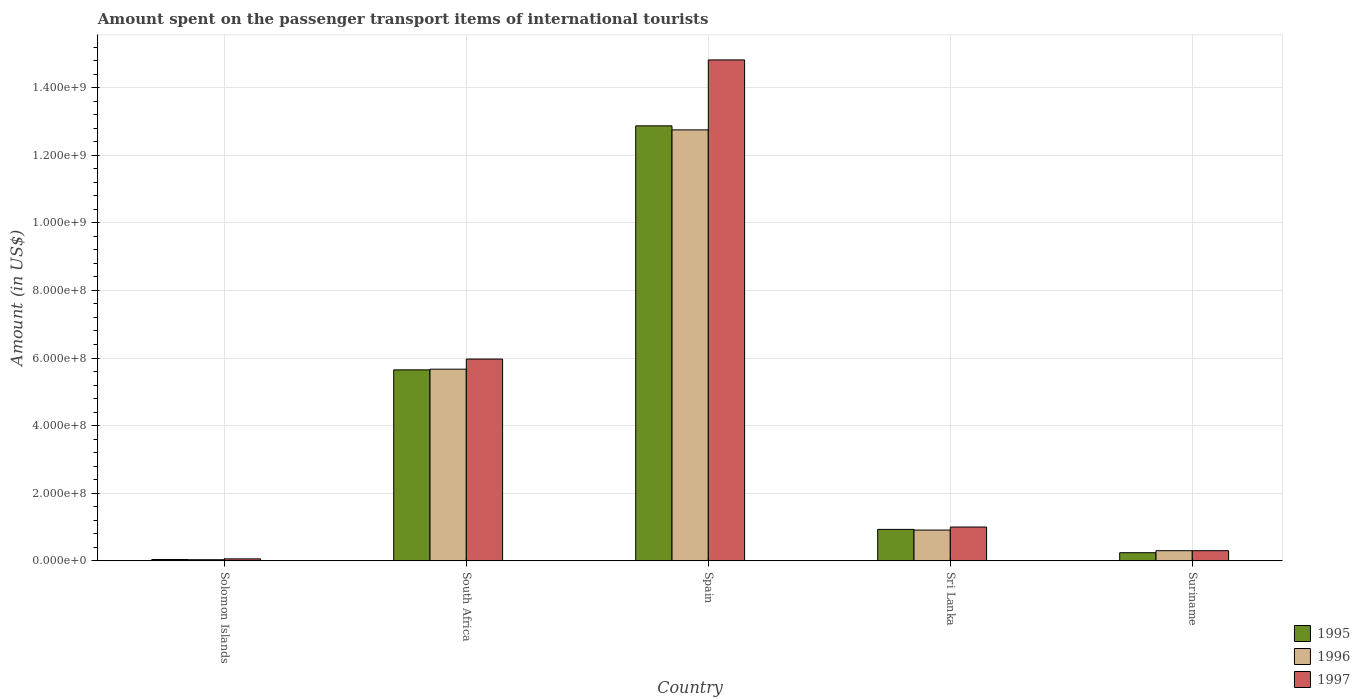Are the number of bars per tick equal to the number of legend labels?
Keep it short and to the point. Yes. Are the number of bars on each tick of the X-axis equal?
Ensure brevity in your answer.  Yes. How many bars are there on the 3rd tick from the right?
Ensure brevity in your answer.  3. What is the label of the 4th group of bars from the left?
Make the answer very short. Sri Lanka. In how many cases, is the number of bars for a given country not equal to the number of legend labels?
Offer a very short reply. 0. What is the amount spent on the passenger transport items of international tourists in 1997 in South Africa?
Make the answer very short. 5.97e+08. Across all countries, what is the maximum amount spent on the passenger transport items of international tourists in 1997?
Provide a short and direct response. 1.48e+09. Across all countries, what is the minimum amount spent on the passenger transport items of international tourists in 1996?
Offer a terse response. 3.30e+06. In which country was the amount spent on the passenger transport items of international tourists in 1995 maximum?
Make the answer very short. Spain. In which country was the amount spent on the passenger transport items of international tourists in 1996 minimum?
Give a very brief answer. Solomon Islands. What is the total amount spent on the passenger transport items of international tourists in 1995 in the graph?
Ensure brevity in your answer.  1.97e+09. What is the difference between the amount spent on the passenger transport items of international tourists in 1996 in Solomon Islands and that in Sri Lanka?
Provide a succinct answer. -8.77e+07. What is the difference between the amount spent on the passenger transport items of international tourists in 1997 in Sri Lanka and the amount spent on the passenger transport items of international tourists in 1995 in Spain?
Your answer should be compact. -1.19e+09. What is the average amount spent on the passenger transport items of international tourists in 1995 per country?
Make the answer very short. 3.95e+08. What is the difference between the amount spent on the passenger transport items of international tourists of/in 1996 and amount spent on the passenger transport items of international tourists of/in 1995 in South Africa?
Give a very brief answer. 2.00e+06. In how many countries, is the amount spent on the passenger transport items of international tourists in 1997 greater than 800000000 US$?
Your answer should be compact. 1. What is the ratio of the amount spent on the passenger transport items of international tourists in 1996 in Solomon Islands to that in South Africa?
Offer a terse response. 0.01. Is the amount spent on the passenger transport items of international tourists in 1995 in Solomon Islands less than that in Suriname?
Provide a succinct answer. Yes. What is the difference between the highest and the second highest amount spent on the passenger transport items of international tourists in 1995?
Your response must be concise. 7.22e+08. What is the difference between the highest and the lowest amount spent on the passenger transport items of international tourists in 1996?
Offer a very short reply. 1.27e+09. In how many countries, is the amount spent on the passenger transport items of international tourists in 1996 greater than the average amount spent on the passenger transport items of international tourists in 1996 taken over all countries?
Ensure brevity in your answer.  2. Is the sum of the amount spent on the passenger transport items of international tourists in 1995 in Spain and Suriname greater than the maximum amount spent on the passenger transport items of international tourists in 1997 across all countries?
Provide a succinct answer. No. What does the 3rd bar from the right in Solomon Islands represents?
Offer a very short reply. 1995. Is it the case that in every country, the sum of the amount spent on the passenger transport items of international tourists in 1996 and amount spent on the passenger transport items of international tourists in 1997 is greater than the amount spent on the passenger transport items of international tourists in 1995?
Your answer should be compact. Yes. How many bars are there?
Offer a terse response. 15. How many countries are there in the graph?
Provide a short and direct response. 5. Does the graph contain grids?
Your answer should be very brief. Yes. What is the title of the graph?
Offer a very short reply. Amount spent on the passenger transport items of international tourists. Does "2003" appear as one of the legend labels in the graph?
Offer a terse response. No. What is the label or title of the Y-axis?
Your answer should be very brief. Amount (in US$). What is the Amount (in US$) of 1995 in Solomon Islands?
Offer a very short reply. 3.90e+06. What is the Amount (in US$) in 1996 in Solomon Islands?
Offer a very short reply. 3.30e+06. What is the Amount (in US$) of 1997 in Solomon Islands?
Make the answer very short. 5.80e+06. What is the Amount (in US$) in 1995 in South Africa?
Offer a very short reply. 5.65e+08. What is the Amount (in US$) of 1996 in South Africa?
Offer a very short reply. 5.67e+08. What is the Amount (in US$) in 1997 in South Africa?
Offer a terse response. 5.97e+08. What is the Amount (in US$) in 1995 in Spain?
Your answer should be very brief. 1.29e+09. What is the Amount (in US$) in 1996 in Spain?
Keep it short and to the point. 1.28e+09. What is the Amount (in US$) of 1997 in Spain?
Offer a very short reply. 1.48e+09. What is the Amount (in US$) in 1995 in Sri Lanka?
Give a very brief answer. 9.30e+07. What is the Amount (in US$) of 1996 in Sri Lanka?
Offer a terse response. 9.10e+07. What is the Amount (in US$) of 1997 in Sri Lanka?
Provide a succinct answer. 1.00e+08. What is the Amount (in US$) of 1995 in Suriname?
Offer a terse response. 2.40e+07. What is the Amount (in US$) in 1996 in Suriname?
Ensure brevity in your answer.  3.00e+07. What is the Amount (in US$) of 1997 in Suriname?
Provide a short and direct response. 3.00e+07. Across all countries, what is the maximum Amount (in US$) of 1995?
Ensure brevity in your answer.  1.29e+09. Across all countries, what is the maximum Amount (in US$) in 1996?
Provide a short and direct response. 1.28e+09. Across all countries, what is the maximum Amount (in US$) in 1997?
Offer a very short reply. 1.48e+09. Across all countries, what is the minimum Amount (in US$) in 1995?
Keep it short and to the point. 3.90e+06. Across all countries, what is the minimum Amount (in US$) in 1996?
Your response must be concise. 3.30e+06. Across all countries, what is the minimum Amount (in US$) in 1997?
Offer a very short reply. 5.80e+06. What is the total Amount (in US$) of 1995 in the graph?
Keep it short and to the point. 1.97e+09. What is the total Amount (in US$) of 1996 in the graph?
Provide a short and direct response. 1.97e+09. What is the total Amount (in US$) in 1997 in the graph?
Offer a very short reply. 2.21e+09. What is the difference between the Amount (in US$) in 1995 in Solomon Islands and that in South Africa?
Your response must be concise. -5.61e+08. What is the difference between the Amount (in US$) in 1996 in Solomon Islands and that in South Africa?
Provide a short and direct response. -5.64e+08. What is the difference between the Amount (in US$) in 1997 in Solomon Islands and that in South Africa?
Provide a short and direct response. -5.91e+08. What is the difference between the Amount (in US$) in 1995 in Solomon Islands and that in Spain?
Ensure brevity in your answer.  -1.28e+09. What is the difference between the Amount (in US$) in 1996 in Solomon Islands and that in Spain?
Offer a very short reply. -1.27e+09. What is the difference between the Amount (in US$) in 1997 in Solomon Islands and that in Spain?
Give a very brief answer. -1.48e+09. What is the difference between the Amount (in US$) of 1995 in Solomon Islands and that in Sri Lanka?
Provide a succinct answer. -8.91e+07. What is the difference between the Amount (in US$) in 1996 in Solomon Islands and that in Sri Lanka?
Provide a succinct answer. -8.77e+07. What is the difference between the Amount (in US$) in 1997 in Solomon Islands and that in Sri Lanka?
Make the answer very short. -9.42e+07. What is the difference between the Amount (in US$) of 1995 in Solomon Islands and that in Suriname?
Provide a short and direct response. -2.01e+07. What is the difference between the Amount (in US$) of 1996 in Solomon Islands and that in Suriname?
Provide a succinct answer. -2.67e+07. What is the difference between the Amount (in US$) of 1997 in Solomon Islands and that in Suriname?
Your answer should be compact. -2.42e+07. What is the difference between the Amount (in US$) in 1995 in South Africa and that in Spain?
Offer a very short reply. -7.22e+08. What is the difference between the Amount (in US$) of 1996 in South Africa and that in Spain?
Your answer should be compact. -7.08e+08. What is the difference between the Amount (in US$) of 1997 in South Africa and that in Spain?
Make the answer very short. -8.85e+08. What is the difference between the Amount (in US$) of 1995 in South Africa and that in Sri Lanka?
Give a very brief answer. 4.72e+08. What is the difference between the Amount (in US$) in 1996 in South Africa and that in Sri Lanka?
Your answer should be very brief. 4.76e+08. What is the difference between the Amount (in US$) of 1997 in South Africa and that in Sri Lanka?
Offer a very short reply. 4.97e+08. What is the difference between the Amount (in US$) of 1995 in South Africa and that in Suriname?
Provide a short and direct response. 5.41e+08. What is the difference between the Amount (in US$) of 1996 in South Africa and that in Suriname?
Offer a terse response. 5.37e+08. What is the difference between the Amount (in US$) in 1997 in South Africa and that in Suriname?
Make the answer very short. 5.67e+08. What is the difference between the Amount (in US$) of 1995 in Spain and that in Sri Lanka?
Make the answer very short. 1.19e+09. What is the difference between the Amount (in US$) of 1996 in Spain and that in Sri Lanka?
Your answer should be very brief. 1.18e+09. What is the difference between the Amount (in US$) in 1997 in Spain and that in Sri Lanka?
Your answer should be very brief. 1.38e+09. What is the difference between the Amount (in US$) of 1995 in Spain and that in Suriname?
Give a very brief answer. 1.26e+09. What is the difference between the Amount (in US$) of 1996 in Spain and that in Suriname?
Offer a terse response. 1.24e+09. What is the difference between the Amount (in US$) in 1997 in Spain and that in Suriname?
Offer a terse response. 1.45e+09. What is the difference between the Amount (in US$) in 1995 in Sri Lanka and that in Suriname?
Give a very brief answer. 6.90e+07. What is the difference between the Amount (in US$) in 1996 in Sri Lanka and that in Suriname?
Provide a short and direct response. 6.10e+07. What is the difference between the Amount (in US$) in 1997 in Sri Lanka and that in Suriname?
Your response must be concise. 7.00e+07. What is the difference between the Amount (in US$) of 1995 in Solomon Islands and the Amount (in US$) of 1996 in South Africa?
Provide a succinct answer. -5.63e+08. What is the difference between the Amount (in US$) in 1995 in Solomon Islands and the Amount (in US$) in 1997 in South Africa?
Give a very brief answer. -5.93e+08. What is the difference between the Amount (in US$) of 1996 in Solomon Islands and the Amount (in US$) of 1997 in South Africa?
Keep it short and to the point. -5.94e+08. What is the difference between the Amount (in US$) of 1995 in Solomon Islands and the Amount (in US$) of 1996 in Spain?
Provide a short and direct response. -1.27e+09. What is the difference between the Amount (in US$) in 1995 in Solomon Islands and the Amount (in US$) in 1997 in Spain?
Offer a terse response. -1.48e+09. What is the difference between the Amount (in US$) of 1996 in Solomon Islands and the Amount (in US$) of 1997 in Spain?
Your answer should be compact. -1.48e+09. What is the difference between the Amount (in US$) of 1995 in Solomon Islands and the Amount (in US$) of 1996 in Sri Lanka?
Make the answer very short. -8.71e+07. What is the difference between the Amount (in US$) of 1995 in Solomon Islands and the Amount (in US$) of 1997 in Sri Lanka?
Ensure brevity in your answer.  -9.61e+07. What is the difference between the Amount (in US$) of 1996 in Solomon Islands and the Amount (in US$) of 1997 in Sri Lanka?
Keep it short and to the point. -9.67e+07. What is the difference between the Amount (in US$) in 1995 in Solomon Islands and the Amount (in US$) in 1996 in Suriname?
Give a very brief answer. -2.61e+07. What is the difference between the Amount (in US$) of 1995 in Solomon Islands and the Amount (in US$) of 1997 in Suriname?
Offer a terse response. -2.61e+07. What is the difference between the Amount (in US$) of 1996 in Solomon Islands and the Amount (in US$) of 1997 in Suriname?
Provide a succinct answer. -2.67e+07. What is the difference between the Amount (in US$) of 1995 in South Africa and the Amount (in US$) of 1996 in Spain?
Offer a terse response. -7.10e+08. What is the difference between the Amount (in US$) of 1995 in South Africa and the Amount (in US$) of 1997 in Spain?
Give a very brief answer. -9.17e+08. What is the difference between the Amount (in US$) of 1996 in South Africa and the Amount (in US$) of 1997 in Spain?
Your answer should be very brief. -9.15e+08. What is the difference between the Amount (in US$) of 1995 in South Africa and the Amount (in US$) of 1996 in Sri Lanka?
Your answer should be compact. 4.74e+08. What is the difference between the Amount (in US$) in 1995 in South Africa and the Amount (in US$) in 1997 in Sri Lanka?
Keep it short and to the point. 4.65e+08. What is the difference between the Amount (in US$) of 1996 in South Africa and the Amount (in US$) of 1997 in Sri Lanka?
Your answer should be compact. 4.67e+08. What is the difference between the Amount (in US$) of 1995 in South Africa and the Amount (in US$) of 1996 in Suriname?
Give a very brief answer. 5.35e+08. What is the difference between the Amount (in US$) of 1995 in South Africa and the Amount (in US$) of 1997 in Suriname?
Offer a terse response. 5.35e+08. What is the difference between the Amount (in US$) of 1996 in South Africa and the Amount (in US$) of 1997 in Suriname?
Provide a short and direct response. 5.37e+08. What is the difference between the Amount (in US$) of 1995 in Spain and the Amount (in US$) of 1996 in Sri Lanka?
Offer a terse response. 1.20e+09. What is the difference between the Amount (in US$) of 1995 in Spain and the Amount (in US$) of 1997 in Sri Lanka?
Offer a terse response. 1.19e+09. What is the difference between the Amount (in US$) in 1996 in Spain and the Amount (in US$) in 1997 in Sri Lanka?
Your response must be concise. 1.18e+09. What is the difference between the Amount (in US$) in 1995 in Spain and the Amount (in US$) in 1996 in Suriname?
Make the answer very short. 1.26e+09. What is the difference between the Amount (in US$) of 1995 in Spain and the Amount (in US$) of 1997 in Suriname?
Offer a terse response. 1.26e+09. What is the difference between the Amount (in US$) in 1996 in Spain and the Amount (in US$) in 1997 in Suriname?
Give a very brief answer. 1.24e+09. What is the difference between the Amount (in US$) of 1995 in Sri Lanka and the Amount (in US$) of 1996 in Suriname?
Your response must be concise. 6.30e+07. What is the difference between the Amount (in US$) in 1995 in Sri Lanka and the Amount (in US$) in 1997 in Suriname?
Provide a short and direct response. 6.30e+07. What is the difference between the Amount (in US$) in 1996 in Sri Lanka and the Amount (in US$) in 1997 in Suriname?
Your answer should be very brief. 6.10e+07. What is the average Amount (in US$) of 1995 per country?
Offer a very short reply. 3.95e+08. What is the average Amount (in US$) of 1996 per country?
Offer a terse response. 3.93e+08. What is the average Amount (in US$) of 1997 per country?
Keep it short and to the point. 4.43e+08. What is the difference between the Amount (in US$) in 1995 and Amount (in US$) in 1996 in Solomon Islands?
Make the answer very short. 6.00e+05. What is the difference between the Amount (in US$) of 1995 and Amount (in US$) of 1997 in Solomon Islands?
Your answer should be very brief. -1.90e+06. What is the difference between the Amount (in US$) of 1996 and Amount (in US$) of 1997 in Solomon Islands?
Your answer should be compact. -2.50e+06. What is the difference between the Amount (in US$) in 1995 and Amount (in US$) in 1996 in South Africa?
Offer a very short reply. -2.00e+06. What is the difference between the Amount (in US$) of 1995 and Amount (in US$) of 1997 in South Africa?
Give a very brief answer. -3.20e+07. What is the difference between the Amount (in US$) of 1996 and Amount (in US$) of 1997 in South Africa?
Offer a very short reply. -3.00e+07. What is the difference between the Amount (in US$) in 1995 and Amount (in US$) in 1997 in Spain?
Offer a terse response. -1.95e+08. What is the difference between the Amount (in US$) in 1996 and Amount (in US$) in 1997 in Spain?
Your response must be concise. -2.07e+08. What is the difference between the Amount (in US$) in 1995 and Amount (in US$) in 1996 in Sri Lanka?
Offer a terse response. 2.00e+06. What is the difference between the Amount (in US$) in 1995 and Amount (in US$) in 1997 in Sri Lanka?
Give a very brief answer. -7.00e+06. What is the difference between the Amount (in US$) of 1996 and Amount (in US$) of 1997 in Sri Lanka?
Offer a very short reply. -9.00e+06. What is the difference between the Amount (in US$) in 1995 and Amount (in US$) in 1996 in Suriname?
Provide a short and direct response. -6.00e+06. What is the difference between the Amount (in US$) of 1995 and Amount (in US$) of 1997 in Suriname?
Provide a succinct answer. -6.00e+06. What is the difference between the Amount (in US$) of 1996 and Amount (in US$) of 1997 in Suriname?
Ensure brevity in your answer.  0. What is the ratio of the Amount (in US$) in 1995 in Solomon Islands to that in South Africa?
Offer a very short reply. 0.01. What is the ratio of the Amount (in US$) of 1996 in Solomon Islands to that in South Africa?
Your answer should be compact. 0.01. What is the ratio of the Amount (in US$) in 1997 in Solomon Islands to that in South Africa?
Make the answer very short. 0.01. What is the ratio of the Amount (in US$) in 1995 in Solomon Islands to that in Spain?
Provide a short and direct response. 0. What is the ratio of the Amount (in US$) in 1996 in Solomon Islands to that in Spain?
Your answer should be compact. 0. What is the ratio of the Amount (in US$) of 1997 in Solomon Islands to that in Spain?
Offer a very short reply. 0. What is the ratio of the Amount (in US$) in 1995 in Solomon Islands to that in Sri Lanka?
Provide a succinct answer. 0.04. What is the ratio of the Amount (in US$) of 1996 in Solomon Islands to that in Sri Lanka?
Your response must be concise. 0.04. What is the ratio of the Amount (in US$) in 1997 in Solomon Islands to that in Sri Lanka?
Provide a short and direct response. 0.06. What is the ratio of the Amount (in US$) of 1995 in Solomon Islands to that in Suriname?
Keep it short and to the point. 0.16. What is the ratio of the Amount (in US$) of 1996 in Solomon Islands to that in Suriname?
Your answer should be compact. 0.11. What is the ratio of the Amount (in US$) in 1997 in Solomon Islands to that in Suriname?
Provide a short and direct response. 0.19. What is the ratio of the Amount (in US$) of 1995 in South Africa to that in Spain?
Offer a terse response. 0.44. What is the ratio of the Amount (in US$) in 1996 in South Africa to that in Spain?
Offer a terse response. 0.44. What is the ratio of the Amount (in US$) in 1997 in South Africa to that in Spain?
Offer a very short reply. 0.4. What is the ratio of the Amount (in US$) in 1995 in South Africa to that in Sri Lanka?
Your answer should be compact. 6.08. What is the ratio of the Amount (in US$) in 1996 in South Africa to that in Sri Lanka?
Provide a short and direct response. 6.23. What is the ratio of the Amount (in US$) of 1997 in South Africa to that in Sri Lanka?
Ensure brevity in your answer.  5.97. What is the ratio of the Amount (in US$) in 1995 in South Africa to that in Suriname?
Offer a very short reply. 23.54. What is the ratio of the Amount (in US$) in 1996 in South Africa to that in Suriname?
Provide a succinct answer. 18.9. What is the ratio of the Amount (in US$) in 1997 in South Africa to that in Suriname?
Ensure brevity in your answer.  19.9. What is the ratio of the Amount (in US$) in 1995 in Spain to that in Sri Lanka?
Offer a terse response. 13.84. What is the ratio of the Amount (in US$) in 1996 in Spain to that in Sri Lanka?
Make the answer very short. 14.01. What is the ratio of the Amount (in US$) in 1997 in Spain to that in Sri Lanka?
Give a very brief answer. 14.82. What is the ratio of the Amount (in US$) of 1995 in Spain to that in Suriname?
Your answer should be very brief. 53.62. What is the ratio of the Amount (in US$) in 1996 in Spain to that in Suriname?
Provide a short and direct response. 42.5. What is the ratio of the Amount (in US$) of 1997 in Spain to that in Suriname?
Offer a very short reply. 49.4. What is the ratio of the Amount (in US$) in 1995 in Sri Lanka to that in Suriname?
Your answer should be compact. 3.88. What is the ratio of the Amount (in US$) of 1996 in Sri Lanka to that in Suriname?
Your answer should be very brief. 3.03. What is the difference between the highest and the second highest Amount (in US$) in 1995?
Your answer should be very brief. 7.22e+08. What is the difference between the highest and the second highest Amount (in US$) of 1996?
Provide a succinct answer. 7.08e+08. What is the difference between the highest and the second highest Amount (in US$) in 1997?
Keep it short and to the point. 8.85e+08. What is the difference between the highest and the lowest Amount (in US$) of 1995?
Your response must be concise. 1.28e+09. What is the difference between the highest and the lowest Amount (in US$) in 1996?
Your answer should be compact. 1.27e+09. What is the difference between the highest and the lowest Amount (in US$) of 1997?
Your response must be concise. 1.48e+09. 